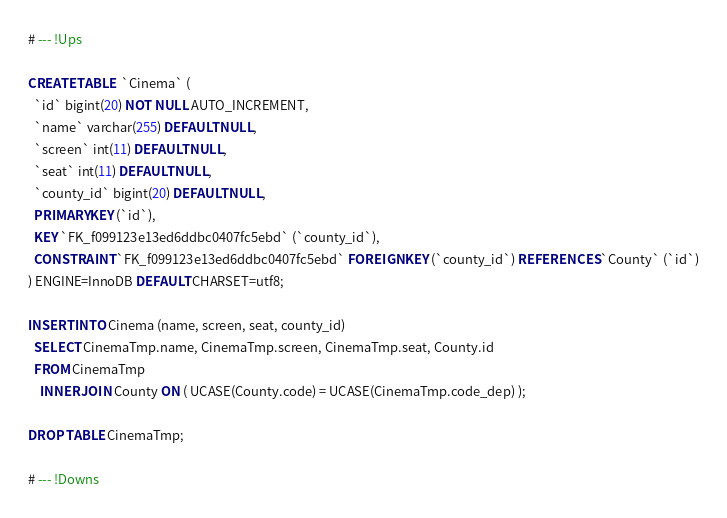<code> <loc_0><loc_0><loc_500><loc_500><_SQL_># --- !Ups

CREATE TABLE  `Cinema` (
  `id` bigint(20) NOT NULL AUTO_INCREMENT,
  `name` varchar(255) DEFAULT NULL,
  `screen` int(11) DEFAULT NULL,
  `seat` int(11) DEFAULT NULL,
  `county_id` bigint(20) DEFAULT NULL,
  PRIMARY KEY (`id`),
  KEY `FK_f099123e13ed6ddbc0407fc5ebd` (`county_id`),
  CONSTRAINT `FK_f099123e13ed6ddbc0407fc5ebd` FOREIGN KEY (`county_id`) REFERENCES `County` (`id`)
) ENGINE=InnoDB DEFAULT CHARSET=utf8;

INSERT INTO Cinema (name, screen, seat, county_id)
  SELECT CinemaTmp.name, CinemaTmp.screen, CinemaTmp.seat, County.id
  FROM CinemaTmp
    INNER JOIN County ON ( UCASE(County.code) = UCASE(CinemaTmp.code_dep) );

DROP TABLE CinemaTmp;

# --- !Downs

</code> 